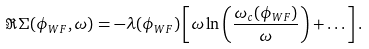Convert formula to latex. <formula><loc_0><loc_0><loc_500><loc_500>\Re \Sigma ( \phi _ { W F } , \omega ) = - \lambda ( \phi _ { W F } ) \left [ \omega \ln \left ( \frac { \omega _ { c } ( \phi _ { W F } ) } { \omega } \right ) + \dots \right ] .</formula> 